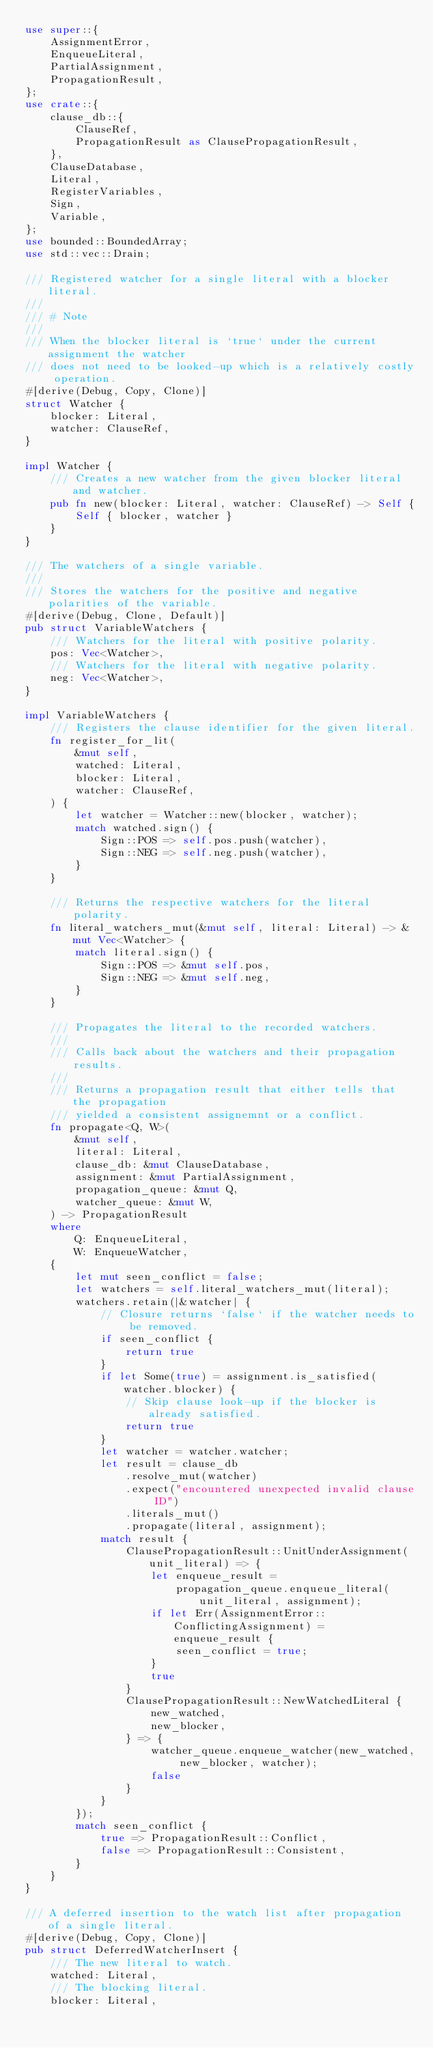<code> <loc_0><loc_0><loc_500><loc_500><_Rust_>use super::{
    AssignmentError,
    EnqueueLiteral,
    PartialAssignment,
    PropagationResult,
};
use crate::{
    clause_db::{
        ClauseRef,
        PropagationResult as ClausePropagationResult,
    },
    ClauseDatabase,
    Literal,
    RegisterVariables,
    Sign,
    Variable,
};
use bounded::BoundedArray;
use std::vec::Drain;

/// Registered watcher for a single literal with a blocker literal.
///
/// # Note
///
/// When the blocker literal is `true` under the current assignment the watcher
/// does not need to be looked-up which is a relatively costly operation.
#[derive(Debug, Copy, Clone)]
struct Watcher {
    blocker: Literal,
    watcher: ClauseRef,
}

impl Watcher {
    /// Creates a new watcher from the given blocker literal and watcher.
    pub fn new(blocker: Literal, watcher: ClauseRef) -> Self {
        Self { blocker, watcher }
    }
}

/// The watchers of a single variable.
///
/// Stores the watchers for the positive and negative polarities of the variable.
#[derive(Debug, Clone, Default)]
pub struct VariableWatchers {
    /// Watchers for the literal with positive polarity.
    pos: Vec<Watcher>,
    /// Watchers for the literal with negative polarity.
    neg: Vec<Watcher>,
}

impl VariableWatchers {
    /// Registers the clause identifier for the given literal.
    fn register_for_lit(
        &mut self,
        watched: Literal,
        blocker: Literal,
        watcher: ClauseRef,
    ) {
        let watcher = Watcher::new(blocker, watcher);
        match watched.sign() {
            Sign::POS => self.pos.push(watcher),
            Sign::NEG => self.neg.push(watcher),
        }
    }

    /// Returns the respective watchers for the literal polarity.
    fn literal_watchers_mut(&mut self, literal: Literal) -> &mut Vec<Watcher> {
        match literal.sign() {
            Sign::POS => &mut self.pos,
            Sign::NEG => &mut self.neg,
        }
    }

    /// Propagates the literal to the recorded watchers.
    ///
    /// Calls back about the watchers and their propagation results.
    ///
    /// Returns a propagation result that either tells that the propagation
    /// yielded a consistent assignemnt or a conflict.
    fn propagate<Q, W>(
        &mut self,
        literal: Literal,
        clause_db: &mut ClauseDatabase,
        assignment: &mut PartialAssignment,
        propagation_queue: &mut Q,
        watcher_queue: &mut W,
    ) -> PropagationResult
    where
        Q: EnqueueLiteral,
        W: EnqueueWatcher,
    {
        let mut seen_conflict = false;
        let watchers = self.literal_watchers_mut(literal);
        watchers.retain(|&watcher| {
            // Closure returns `false` if the watcher needs to be removed.
            if seen_conflict {
                return true
            }
            if let Some(true) = assignment.is_satisfied(watcher.blocker) {
                // Skip clause look-up if the blocker is already satisfied.
                return true
            }
            let watcher = watcher.watcher;
            let result = clause_db
                .resolve_mut(watcher)
                .expect("encountered unexpected invalid clause ID")
                .literals_mut()
                .propagate(literal, assignment);
            match result {
                ClausePropagationResult::UnitUnderAssignment(unit_literal) => {
                    let enqueue_result =
                        propagation_queue.enqueue_literal(unit_literal, assignment);
                    if let Err(AssignmentError::ConflictingAssignment) = enqueue_result {
                        seen_conflict = true;
                    }
                    true
                }
                ClausePropagationResult::NewWatchedLiteral {
                    new_watched,
                    new_blocker,
                } => {
                    watcher_queue.enqueue_watcher(new_watched, new_blocker, watcher);
                    false
                }
            }
        });
        match seen_conflict {
            true => PropagationResult::Conflict,
            false => PropagationResult::Consistent,
        }
    }
}

/// A deferred insertion to the watch list after propagation of a single literal.
#[derive(Debug, Copy, Clone)]
pub struct DeferredWatcherInsert {
    /// The new literal to watch.
    watched: Literal,
    /// The blocking literal.
    blocker: Literal,</code> 